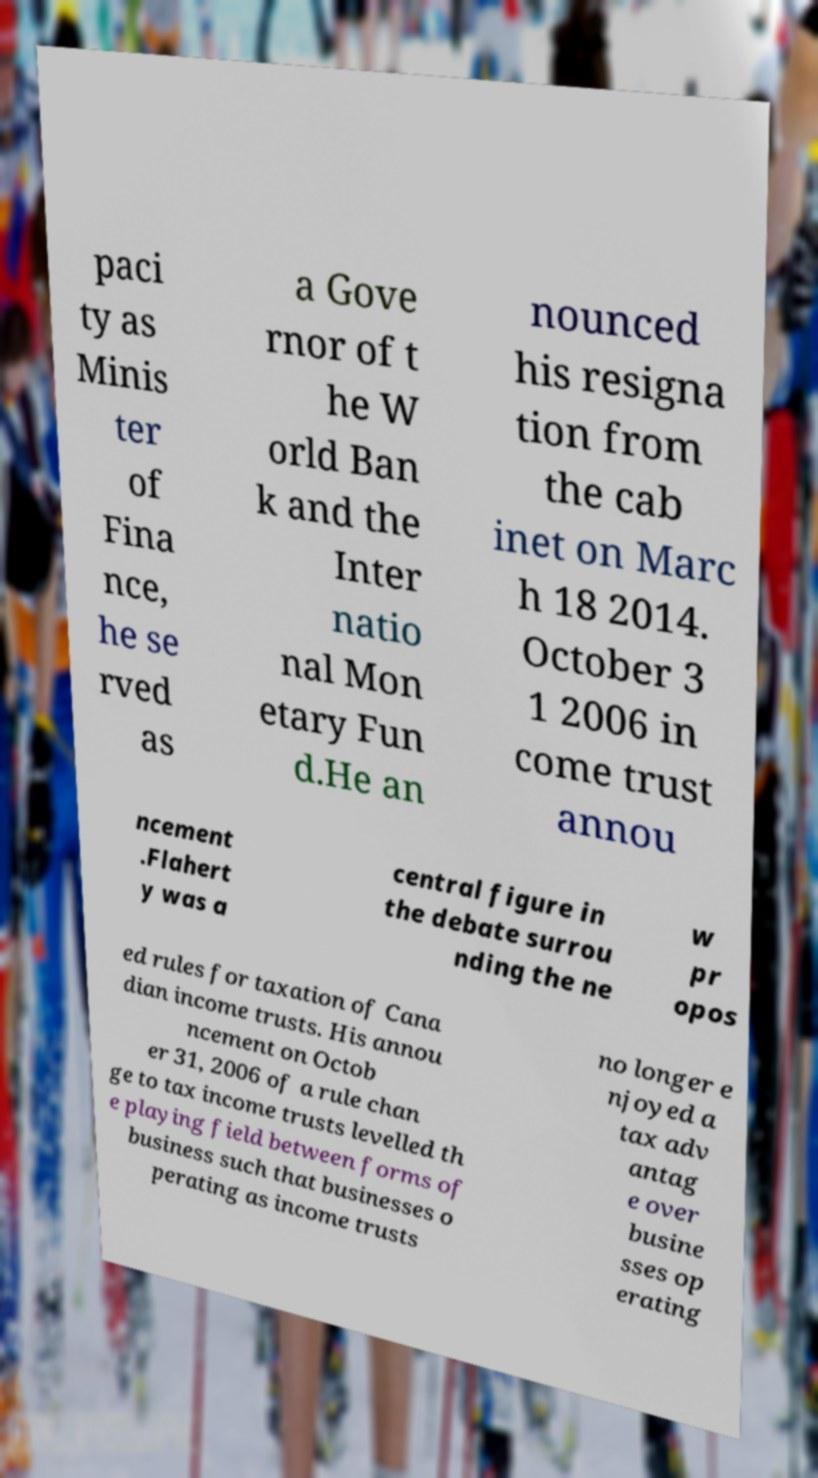Please read and relay the text visible in this image. What does it say? paci ty as Minis ter of Fina nce, he se rved as a Gove rnor of t he W orld Ban k and the Inter natio nal Mon etary Fun d.He an nounced his resigna tion from the cab inet on Marc h 18 2014. October 3 1 2006 in come trust annou ncement .Flahert y was a central figure in the debate surrou nding the ne w pr opos ed rules for taxation of Cana dian income trusts. His annou ncement on Octob er 31, 2006 of a rule chan ge to tax income trusts levelled th e playing field between forms of business such that businesses o perating as income trusts no longer e njoyed a tax adv antag e over busine sses op erating 